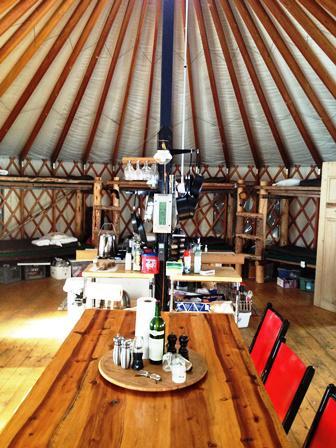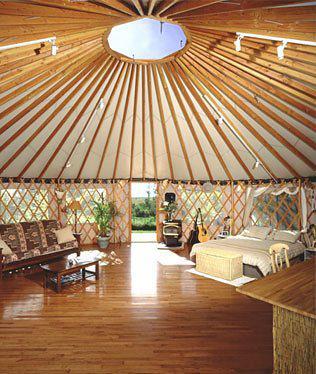The first image is the image on the left, the second image is the image on the right. Examine the images to the left and right. Is the description "The interior of a round house shows its fan-shaped ceiling and lattice walls." accurate? Answer yes or no. Yes. The first image is the image on the left, the second image is the image on the right. Considering the images on both sides, is "All of the images display the interior of the hut." valid? Answer yes or no. Yes. 